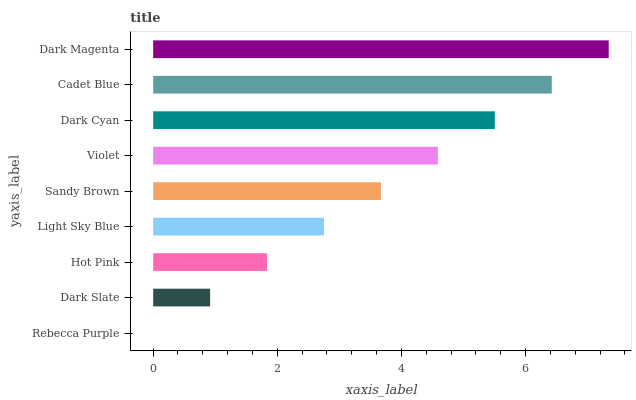Is Rebecca Purple the minimum?
Answer yes or no. Yes. Is Dark Magenta the maximum?
Answer yes or no. Yes. Is Dark Slate the minimum?
Answer yes or no. No. Is Dark Slate the maximum?
Answer yes or no. No. Is Dark Slate greater than Rebecca Purple?
Answer yes or no. Yes. Is Rebecca Purple less than Dark Slate?
Answer yes or no. Yes. Is Rebecca Purple greater than Dark Slate?
Answer yes or no. No. Is Dark Slate less than Rebecca Purple?
Answer yes or no. No. Is Sandy Brown the high median?
Answer yes or no. Yes. Is Sandy Brown the low median?
Answer yes or no. Yes. Is Light Sky Blue the high median?
Answer yes or no. No. Is Rebecca Purple the low median?
Answer yes or no. No. 